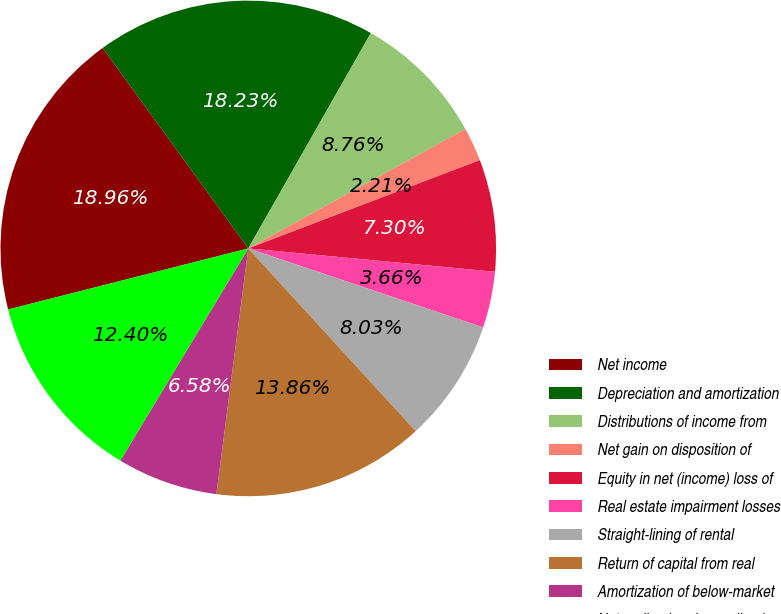Convert chart to OTSL. <chart><loc_0><loc_0><loc_500><loc_500><pie_chart><fcel>Net income<fcel>Depreciation and amortization<fcel>Distributions of income from<fcel>Net gain on disposition of<fcel>Equity in net (income) loss of<fcel>Real estate impairment losses<fcel>Straight-lining of rental<fcel>Return of capital from real<fcel>Amortization of below-market<fcel>Net realized and unrealized<nl><fcel>18.96%<fcel>18.23%<fcel>8.76%<fcel>2.21%<fcel>7.3%<fcel>3.66%<fcel>8.03%<fcel>13.86%<fcel>6.58%<fcel>12.4%<nl></chart> 